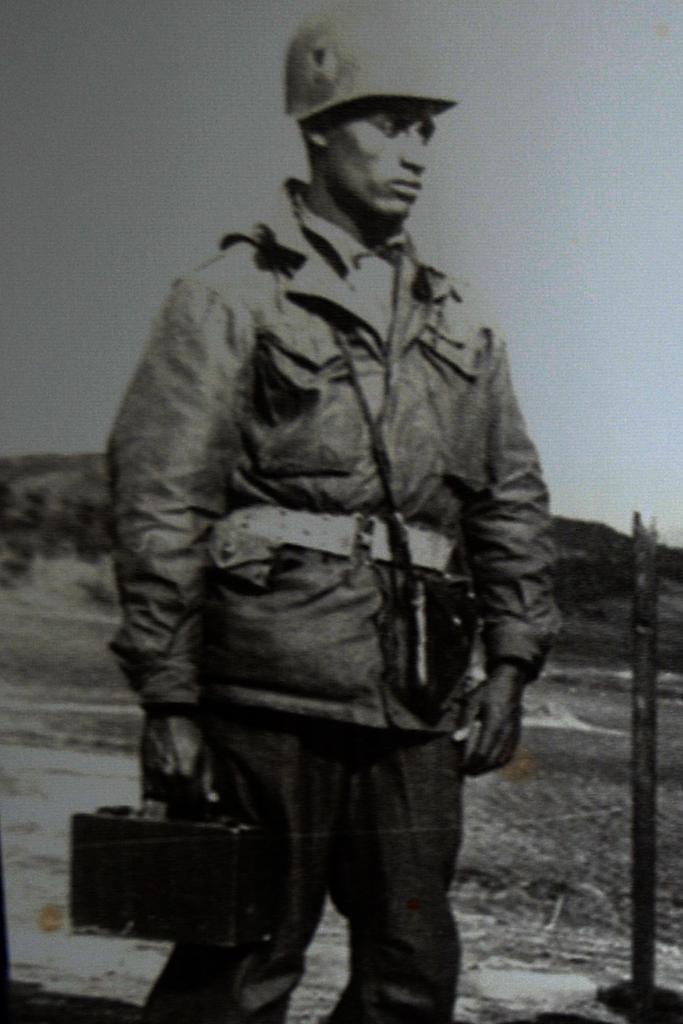Could you give a brief overview of what you see in this image? In this image in the center there is one man who is standing and he is holding a suitcase, in the background there are some mountains. On the right side there is one pole. 